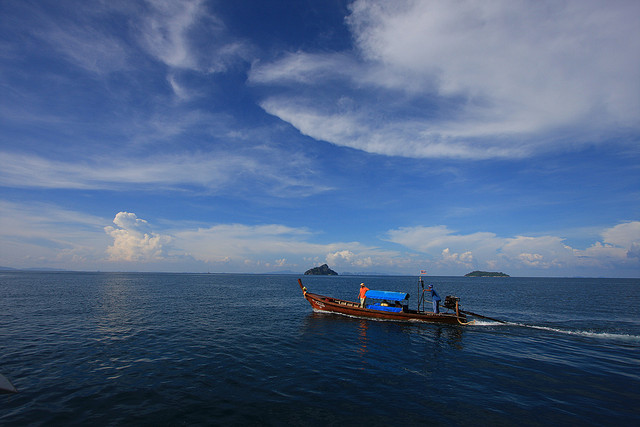<image>Which one of those boats is most likely to have a motor? I don't know which boat is most likely to have a motor. It could be any of them. Which one of those boats is most likely to have a motor? I don't know which one of those boats is most likely to have a motor. It could be the red one, the blue one, or the longboat. 